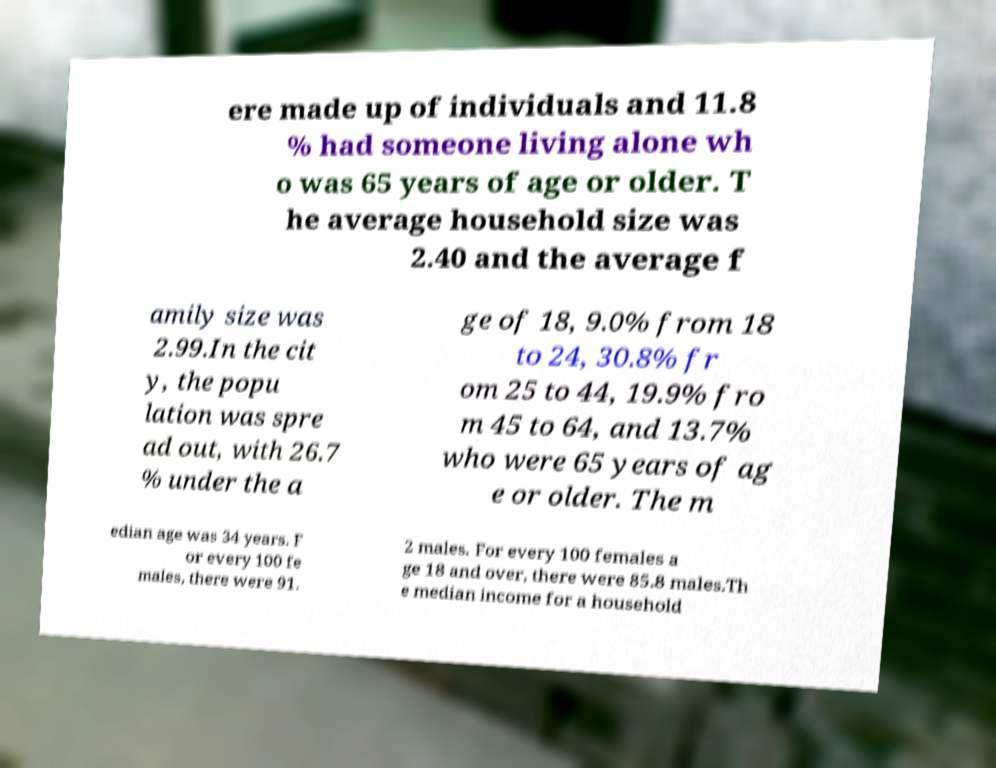Please identify and transcribe the text found in this image. ere made up of individuals and 11.8 % had someone living alone wh o was 65 years of age or older. T he average household size was 2.40 and the average f amily size was 2.99.In the cit y, the popu lation was spre ad out, with 26.7 % under the a ge of 18, 9.0% from 18 to 24, 30.8% fr om 25 to 44, 19.9% fro m 45 to 64, and 13.7% who were 65 years of ag e or older. The m edian age was 34 years. F or every 100 fe males, there were 91. 2 males. For every 100 females a ge 18 and over, there were 85.8 males.Th e median income for a household 